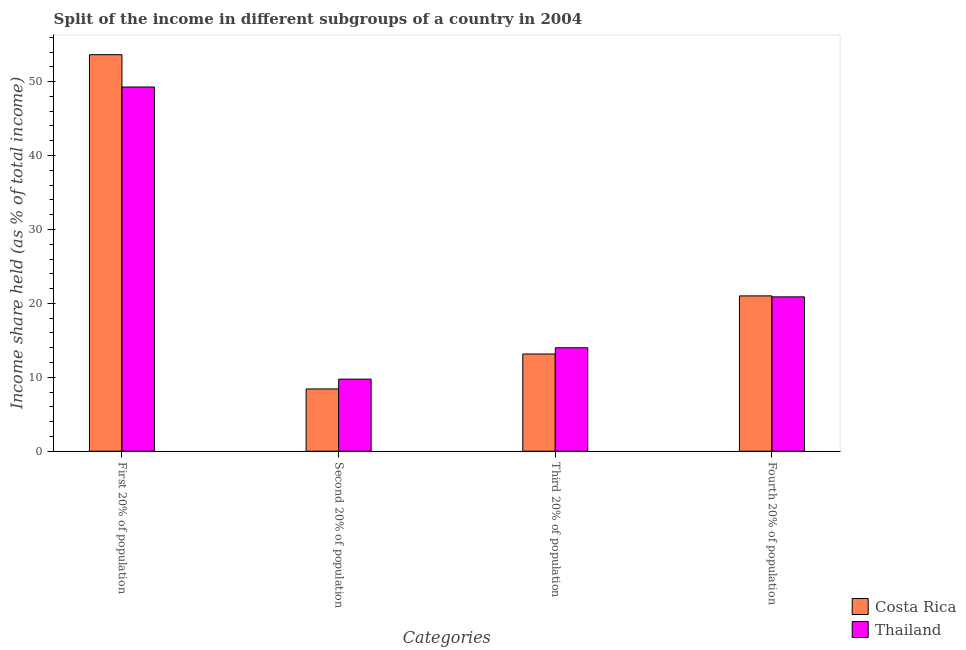How many groups of bars are there?
Make the answer very short. 4. What is the label of the 3rd group of bars from the left?
Your answer should be very brief. Third 20% of population. What is the share of the income held by second 20% of the population in Thailand?
Give a very brief answer. 9.75. Across all countries, what is the maximum share of the income held by first 20% of the population?
Give a very brief answer. 53.64. Across all countries, what is the minimum share of the income held by first 20% of the population?
Your response must be concise. 49.27. In which country was the share of the income held by fourth 20% of the population maximum?
Ensure brevity in your answer.  Costa Rica. In which country was the share of the income held by second 20% of the population minimum?
Offer a terse response. Costa Rica. What is the total share of the income held by first 20% of the population in the graph?
Your answer should be very brief. 102.91. What is the difference between the share of the income held by fourth 20% of the population in Costa Rica and that in Thailand?
Your response must be concise. 0.13. What is the difference between the share of the income held by fourth 20% of the population in Thailand and the share of the income held by first 20% of the population in Costa Rica?
Give a very brief answer. -32.76. What is the average share of the income held by third 20% of the population per country?
Offer a very short reply. 13.57. What is the difference between the share of the income held by third 20% of the population and share of the income held by fourth 20% of the population in Costa Rica?
Offer a very short reply. -7.86. In how many countries, is the share of the income held by first 20% of the population greater than 48 %?
Offer a terse response. 2. What is the ratio of the share of the income held by second 20% of the population in Costa Rica to that in Thailand?
Offer a terse response. 0.86. Is the share of the income held by first 20% of the population in Costa Rica less than that in Thailand?
Ensure brevity in your answer.  No. Is the difference between the share of the income held by first 20% of the population in Thailand and Costa Rica greater than the difference between the share of the income held by third 20% of the population in Thailand and Costa Rica?
Offer a very short reply. No. What is the difference between the highest and the second highest share of the income held by third 20% of the population?
Provide a succinct answer. 0.84. What is the difference between the highest and the lowest share of the income held by fourth 20% of the population?
Offer a very short reply. 0.13. In how many countries, is the share of the income held by third 20% of the population greater than the average share of the income held by third 20% of the population taken over all countries?
Provide a short and direct response. 1. Is the sum of the share of the income held by second 20% of the population in Thailand and Costa Rica greater than the maximum share of the income held by third 20% of the population across all countries?
Keep it short and to the point. Yes. What does the 2nd bar from the left in Third 20% of population represents?
Your answer should be very brief. Thailand. What does the 2nd bar from the right in Second 20% of population represents?
Provide a short and direct response. Costa Rica. Is it the case that in every country, the sum of the share of the income held by first 20% of the population and share of the income held by second 20% of the population is greater than the share of the income held by third 20% of the population?
Your answer should be very brief. Yes. Are all the bars in the graph horizontal?
Offer a very short reply. No. What is the difference between two consecutive major ticks on the Y-axis?
Offer a very short reply. 10. Are the values on the major ticks of Y-axis written in scientific E-notation?
Provide a succinct answer. No. Does the graph contain any zero values?
Provide a short and direct response. No. Does the graph contain grids?
Make the answer very short. No. Where does the legend appear in the graph?
Offer a terse response. Bottom right. How many legend labels are there?
Offer a terse response. 2. How are the legend labels stacked?
Make the answer very short. Vertical. What is the title of the graph?
Keep it short and to the point. Split of the income in different subgroups of a country in 2004. What is the label or title of the X-axis?
Make the answer very short. Categories. What is the label or title of the Y-axis?
Make the answer very short. Income share held (as % of total income). What is the Income share held (as % of total income) of Costa Rica in First 20% of population?
Provide a succinct answer. 53.64. What is the Income share held (as % of total income) in Thailand in First 20% of population?
Offer a very short reply. 49.27. What is the Income share held (as % of total income) of Costa Rica in Second 20% of population?
Provide a short and direct response. 8.42. What is the Income share held (as % of total income) in Thailand in Second 20% of population?
Give a very brief answer. 9.75. What is the Income share held (as % of total income) of Costa Rica in Third 20% of population?
Your answer should be compact. 13.15. What is the Income share held (as % of total income) of Thailand in Third 20% of population?
Offer a very short reply. 13.99. What is the Income share held (as % of total income) in Costa Rica in Fourth 20% of population?
Your response must be concise. 21.01. What is the Income share held (as % of total income) of Thailand in Fourth 20% of population?
Ensure brevity in your answer.  20.88. Across all Categories, what is the maximum Income share held (as % of total income) in Costa Rica?
Keep it short and to the point. 53.64. Across all Categories, what is the maximum Income share held (as % of total income) in Thailand?
Your answer should be very brief. 49.27. Across all Categories, what is the minimum Income share held (as % of total income) of Costa Rica?
Provide a succinct answer. 8.42. Across all Categories, what is the minimum Income share held (as % of total income) in Thailand?
Offer a very short reply. 9.75. What is the total Income share held (as % of total income) of Costa Rica in the graph?
Provide a short and direct response. 96.22. What is the total Income share held (as % of total income) in Thailand in the graph?
Your response must be concise. 93.89. What is the difference between the Income share held (as % of total income) of Costa Rica in First 20% of population and that in Second 20% of population?
Give a very brief answer. 45.22. What is the difference between the Income share held (as % of total income) of Thailand in First 20% of population and that in Second 20% of population?
Give a very brief answer. 39.52. What is the difference between the Income share held (as % of total income) in Costa Rica in First 20% of population and that in Third 20% of population?
Offer a very short reply. 40.49. What is the difference between the Income share held (as % of total income) in Thailand in First 20% of population and that in Third 20% of population?
Give a very brief answer. 35.28. What is the difference between the Income share held (as % of total income) of Costa Rica in First 20% of population and that in Fourth 20% of population?
Keep it short and to the point. 32.63. What is the difference between the Income share held (as % of total income) in Thailand in First 20% of population and that in Fourth 20% of population?
Provide a short and direct response. 28.39. What is the difference between the Income share held (as % of total income) in Costa Rica in Second 20% of population and that in Third 20% of population?
Your answer should be very brief. -4.73. What is the difference between the Income share held (as % of total income) in Thailand in Second 20% of population and that in Third 20% of population?
Offer a very short reply. -4.24. What is the difference between the Income share held (as % of total income) in Costa Rica in Second 20% of population and that in Fourth 20% of population?
Your response must be concise. -12.59. What is the difference between the Income share held (as % of total income) in Thailand in Second 20% of population and that in Fourth 20% of population?
Ensure brevity in your answer.  -11.13. What is the difference between the Income share held (as % of total income) in Costa Rica in Third 20% of population and that in Fourth 20% of population?
Your response must be concise. -7.86. What is the difference between the Income share held (as % of total income) of Thailand in Third 20% of population and that in Fourth 20% of population?
Your answer should be compact. -6.89. What is the difference between the Income share held (as % of total income) in Costa Rica in First 20% of population and the Income share held (as % of total income) in Thailand in Second 20% of population?
Offer a very short reply. 43.89. What is the difference between the Income share held (as % of total income) of Costa Rica in First 20% of population and the Income share held (as % of total income) of Thailand in Third 20% of population?
Your answer should be compact. 39.65. What is the difference between the Income share held (as % of total income) of Costa Rica in First 20% of population and the Income share held (as % of total income) of Thailand in Fourth 20% of population?
Your response must be concise. 32.76. What is the difference between the Income share held (as % of total income) in Costa Rica in Second 20% of population and the Income share held (as % of total income) in Thailand in Third 20% of population?
Your response must be concise. -5.57. What is the difference between the Income share held (as % of total income) of Costa Rica in Second 20% of population and the Income share held (as % of total income) of Thailand in Fourth 20% of population?
Your response must be concise. -12.46. What is the difference between the Income share held (as % of total income) in Costa Rica in Third 20% of population and the Income share held (as % of total income) in Thailand in Fourth 20% of population?
Your answer should be very brief. -7.73. What is the average Income share held (as % of total income) of Costa Rica per Categories?
Offer a terse response. 24.05. What is the average Income share held (as % of total income) in Thailand per Categories?
Provide a short and direct response. 23.47. What is the difference between the Income share held (as % of total income) in Costa Rica and Income share held (as % of total income) in Thailand in First 20% of population?
Offer a very short reply. 4.37. What is the difference between the Income share held (as % of total income) in Costa Rica and Income share held (as % of total income) in Thailand in Second 20% of population?
Keep it short and to the point. -1.33. What is the difference between the Income share held (as % of total income) in Costa Rica and Income share held (as % of total income) in Thailand in Third 20% of population?
Give a very brief answer. -0.84. What is the difference between the Income share held (as % of total income) in Costa Rica and Income share held (as % of total income) in Thailand in Fourth 20% of population?
Your answer should be compact. 0.13. What is the ratio of the Income share held (as % of total income) in Costa Rica in First 20% of population to that in Second 20% of population?
Ensure brevity in your answer.  6.37. What is the ratio of the Income share held (as % of total income) of Thailand in First 20% of population to that in Second 20% of population?
Provide a succinct answer. 5.05. What is the ratio of the Income share held (as % of total income) in Costa Rica in First 20% of population to that in Third 20% of population?
Make the answer very short. 4.08. What is the ratio of the Income share held (as % of total income) of Thailand in First 20% of population to that in Third 20% of population?
Keep it short and to the point. 3.52. What is the ratio of the Income share held (as % of total income) in Costa Rica in First 20% of population to that in Fourth 20% of population?
Your answer should be very brief. 2.55. What is the ratio of the Income share held (as % of total income) of Thailand in First 20% of population to that in Fourth 20% of population?
Offer a very short reply. 2.36. What is the ratio of the Income share held (as % of total income) in Costa Rica in Second 20% of population to that in Third 20% of population?
Make the answer very short. 0.64. What is the ratio of the Income share held (as % of total income) in Thailand in Second 20% of population to that in Third 20% of population?
Give a very brief answer. 0.7. What is the ratio of the Income share held (as % of total income) in Costa Rica in Second 20% of population to that in Fourth 20% of population?
Ensure brevity in your answer.  0.4. What is the ratio of the Income share held (as % of total income) of Thailand in Second 20% of population to that in Fourth 20% of population?
Provide a short and direct response. 0.47. What is the ratio of the Income share held (as % of total income) of Costa Rica in Third 20% of population to that in Fourth 20% of population?
Your answer should be very brief. 0.63. What is the ratio of the Income share held (as % of total income) in Thailand in Third 20% of population to that in Fourth 20% of population?
Provide a short and direct response. 0.67. What is the difference between the highest and the second highest Income share held (as % of total income) of Costa Rica?
Offer a terse response. 32.63. What is the difference between the highest and the second highest Income share held (as % of total income) of Thailand?
Keep it short and to the point. 28.39. What is the difference between the highest and the lowest Income share held (as % of total income) in Costa Rica?
Your answer should be very brief. 45.22. What is the difference between the highest and the lowest Income share held (as % of total income) of Thailand?
Ensure brevity in your answer.  39.52. 